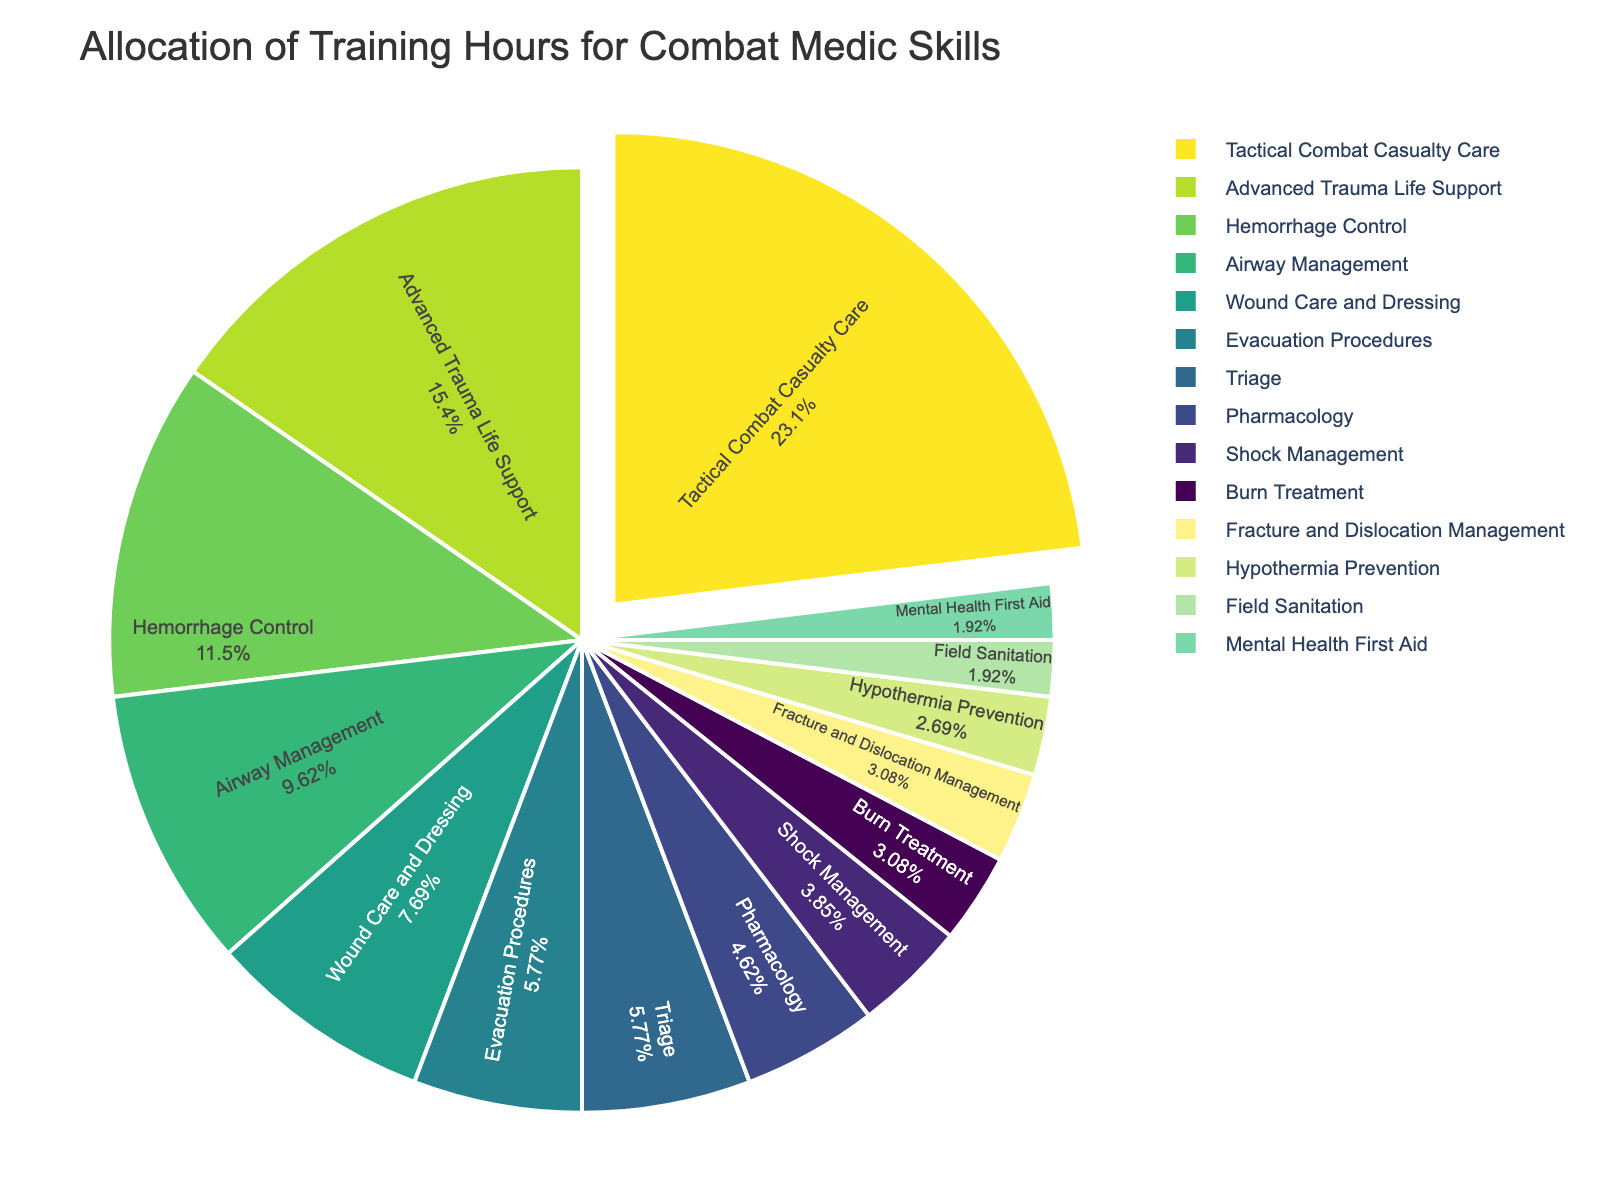What percentage of the training hours is allocated to Tactical Combat Casualty Care? The pie chart shows that Tactical Combat Casualty Care occupies the largest section. By looking at the text inside the pie slice, we can see the percentage.
Answer: 27.3% Which skill has the lowest allocation of training hours? In the pie chart, the smallest slice represents the skill with the least hours. By referring to this slice, we can identify that Field Sanitation and Mental Health First Aid both have the smallest allocations.
Answer: Field Sanitation and Mental Health First Aid How many total hours are allocated to skills related to trauma (Advanced Trauma Life Support, Fracture and Dislocation Management, and Shock Management)? Add the training hours for each trauma-related skill: Advanced Trauma Life Support (40), Fracture and Dislocation Management (8), and Shock Management (10). 40 + 8 + 10 = 58 hours.
Answer: 58 hours What is the difference in training hours between Airway Management and Wound Care and Dressing? Subtract the hours allocated to Wound Care and Dressing (20) from Airway Management (25): 25 - 20 = 5 hours.
Answer: 5 hours Which skills have an equal amount of training hours allocated? By comparing the sizes and labels of the pie chart slices, we can see that Triage and Evacuation Procedures both have the same allocation of 15 hours.
Answer: Triage and Evacuation Procedures Which component takes up a larger percentage of the pie chart: Pharmacology or Shock Management? By visually comparing the sizes of the pie chart slices, we see that Pharmacology (12 hours) has a larger slice than Shock Management (10 hours).
Answer: Pharmacology What is the sum of the training hours for Hemorrhage Control and Burn Treatment? Add the training hours for Hemorrhage Control (30) and Burn Treatment (8): 30 + 8 = 38 hours.
Answer: 38 hours What percentage of training hours is given to skills related to evacuation (Evacuation Procedures and Triage)? Add the hours for Evacuation Procedures (15) and Triage (15), giving 30 hours. Then, find the total training hours by summing all skill hours (gives 300). Calculate the percentage: (30 / 300) * 100 = 10%.
Answer: 10% Which has more training hours, Field Sanitation or Mental Health First Aid, and by how many hours? Field Sanitation and Mental Health First Aid both have 5 hours each. Therefore, there is no difference.
Answer: No difference What percentage of the total training hours is allocated for Hypothermia Prevention, compared to the total? Hypothermia Prevention has 7 hours. The total training hours is 300. Calculate the percentage: (7 / 300) * 100 = 2.3%.
Answer: 2.3% 